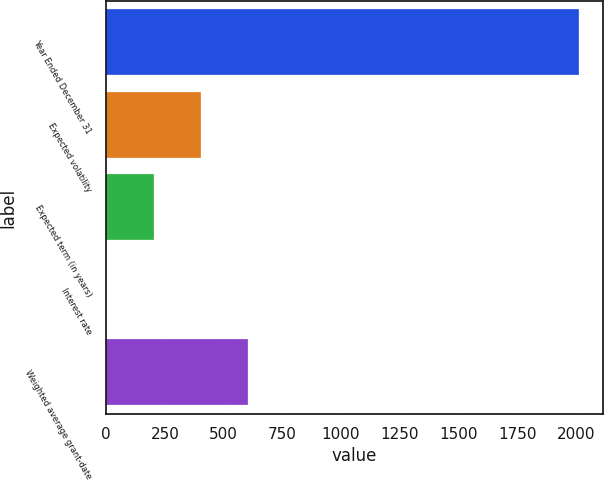<chart> <loc_0><loc_0><loc_500><loc_500><bar_chart><fcel>Year Ended December 31<fcel>Expected volatility<fcel>Expected term (in years)<fcel>Interest rate<fcel>Weighted average grant-date<nl><fcel>2015<fcel>403.8<fcel>202.4<fcel>1<fcel>605.2<nl></chart> 